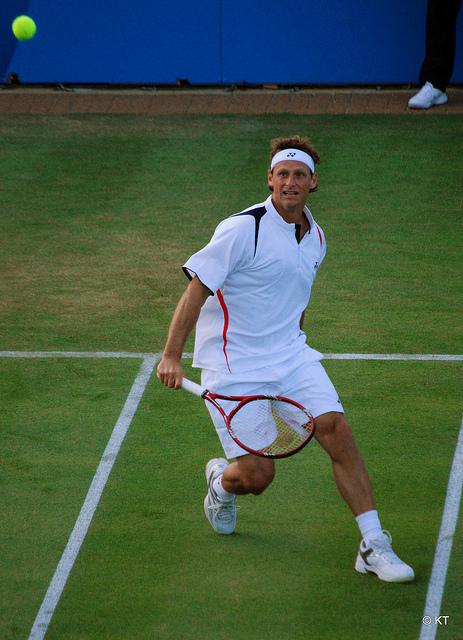What game are they playing?
Short answer required. Tennis. What is he?
Write a very short answer. Tennis player. What sport is the man playing?
Write a very short answer. Tennis. What is on this man's head?
Quick response, please. Headband. Is the grass fake?
Be succinct. No. What is the expression of the man in white shirt?
Give a very brief answer. Happy. What is the boy doing?
Be succinct. Tennis. 